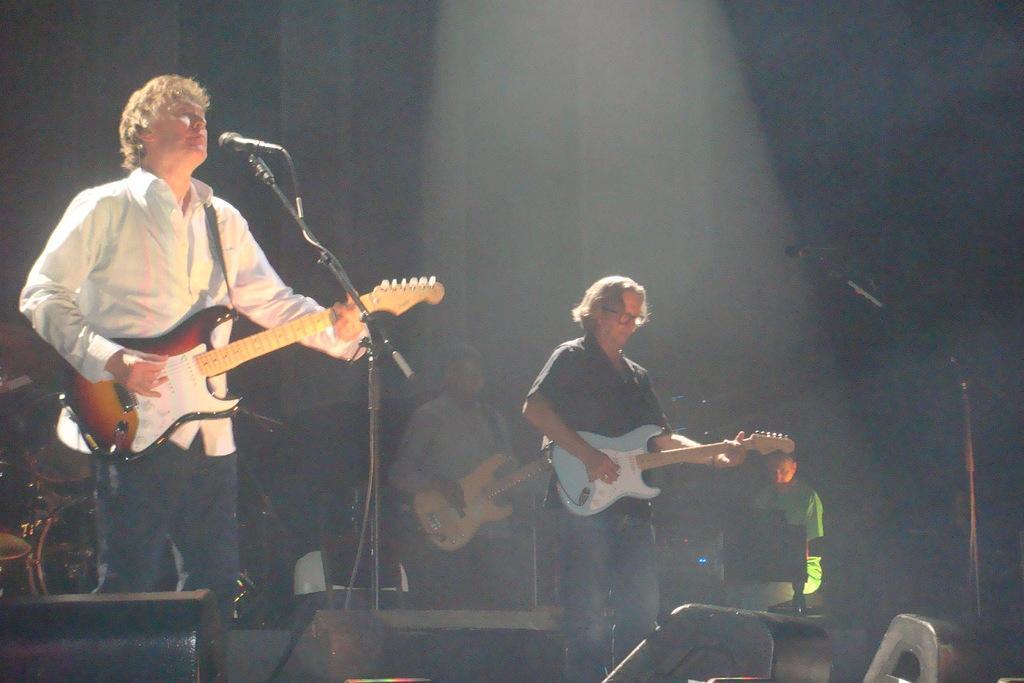Could you give a brief overview of what you see in this image? In this image there are four men three men are playing guitar in front of them there is a mic. 